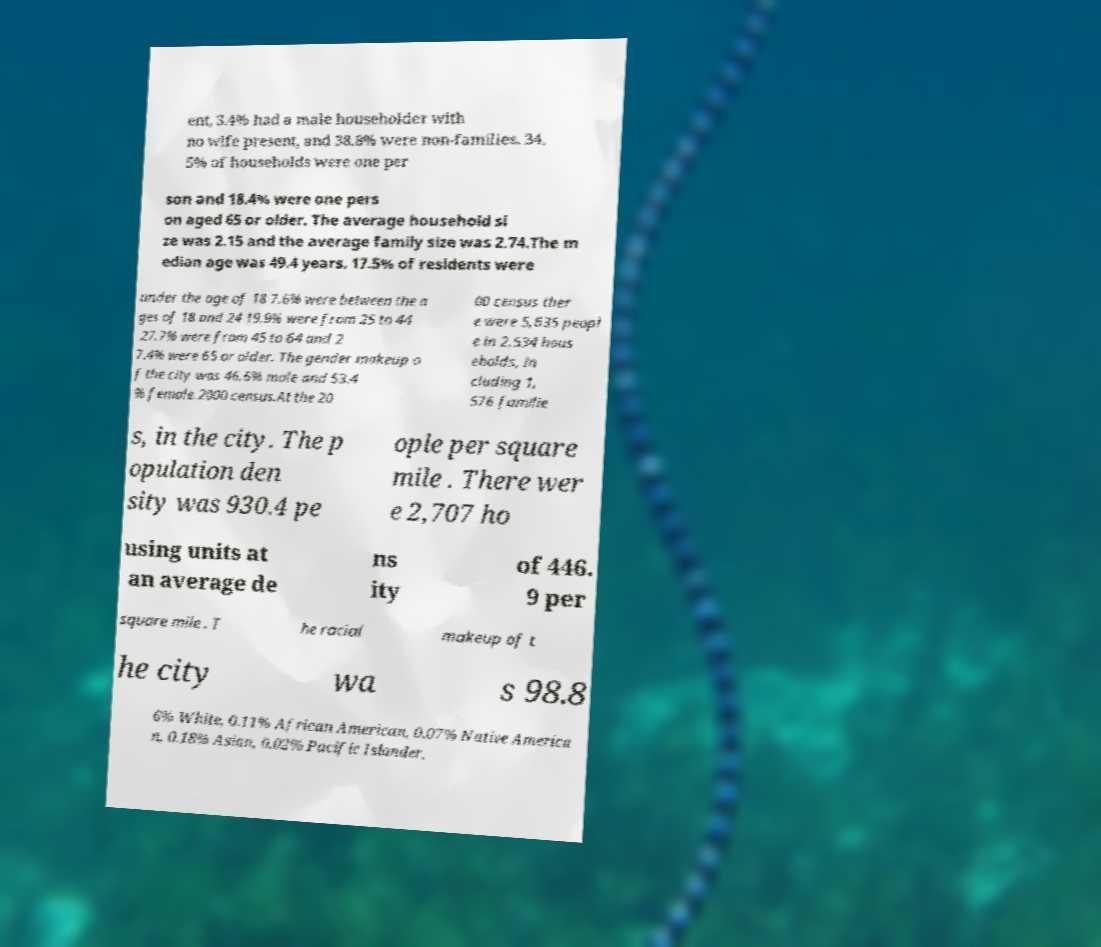Could you assist in decoding the text presented in this image and type it out clearly? ent, 3.4% had a male householder with no wife present, and 38.8% were non-families. 34. 5% of households were one per son and 18.4% were one pers on aged 65 or older. The average household si ze was 2.15 and the average family size was 2.74.The m edian age was 49.4 years. 17.5% of residents were under the age of 18 7.6% were between the a ges of 18 and 24 19.9% were from 25 to 44 27.7% were from 45 to 64 and 2 7.4% were 65 or older. The gender makeup o f the city was 46.6% male and 53.4 % female.2000 census.At the 20 00 census ther e were 5,635 peopl e in 2,534 hous eholds, in cluding 1, 576 familie s, in the city. The p opulation den sity was 930.4 pe ople per square mile . There wer e 2,707 ho using units at an average de ns ity of 446. 9 per square mile . T he racial makeup of t he city wa s 98.8 6% White, 0.11% African American, 0.07% Native America n, 0.18% Asian, 0.02% Pacific Islander, 